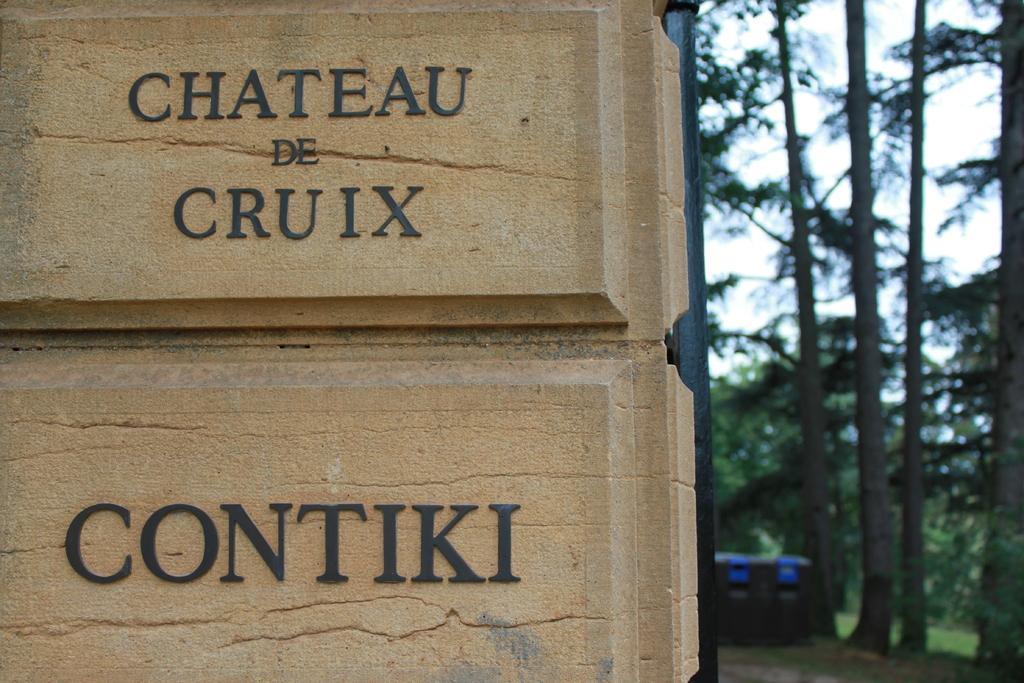Please provide a concise description of this image. On the left side of the image there is a wall with names. On the right side of the image there are trees. 